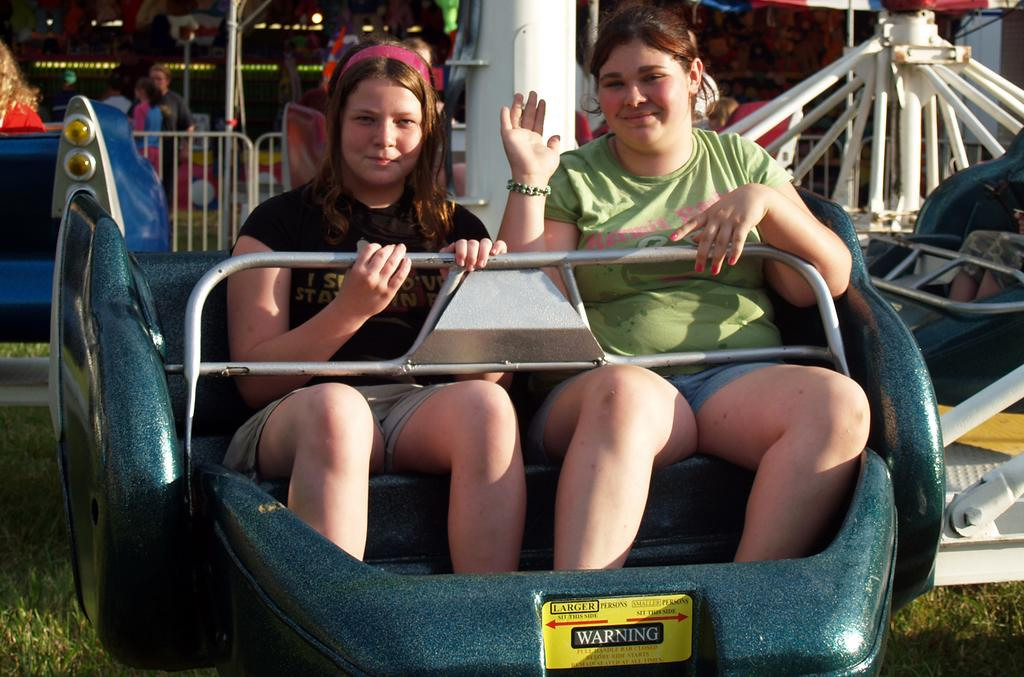How many women are in the image? There are two women in the image. What are the women doing in the image? The women are sitting in a roller coaster. What can be seen at the bottom of the image? There is grass visible at the bottom of the image. What is present in the background of the image? There are barricades and people visible in the background of the image. What is the price of the nation depicted in the image? There is no nation depicted in the image, and therefore no price can be determined. How does the image demand the attention of the viewer? The image does not actively demand the attention of the viewer; it simply presents the scene of two women in a roller coaster. 